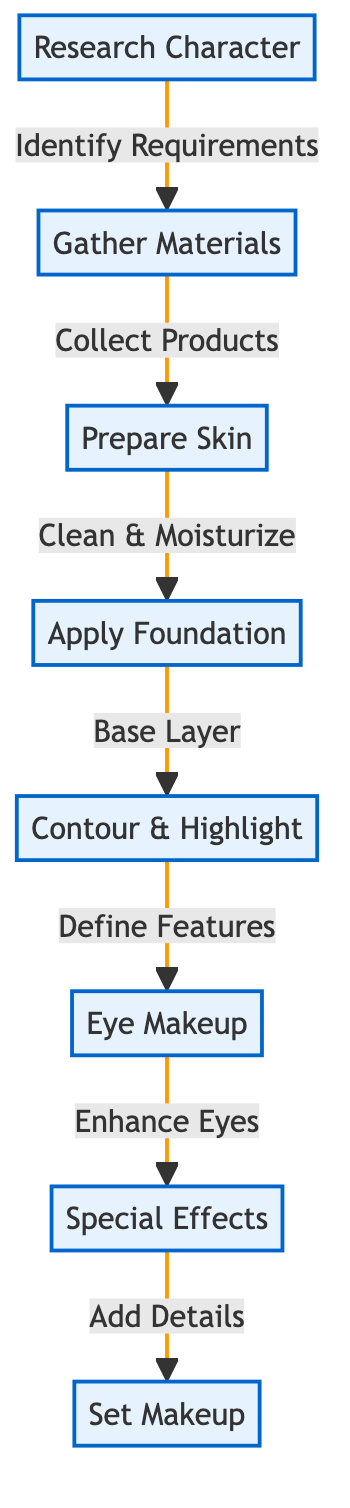What is the first step in the process of creating a movie character makeup look? The first step is represented by the node labeled "Research Character." This is the initial action identified in the diagram.
Answer: Research Character How many main steps are there in the makeup process? By counting the distinct process nodes in the diagram, we find there are eight main steps listed, from "Research Character" to "Set Makeup."
Answer: 8 What is the relationship between "Gather Materials" and "Prepare Skin"? The relationship is represented by the arrow labeled "Collect Products." This indicates that "Gather Materials" leads to the next step of "Prepare Skin."
Answer: Collect Products What is the final action in the makeup creation process? The final action is indicated by the last node in the sequence, "Set Makeup." This is the last step that follows after all other processes are completed.
Answer: Set Makeup Which step involves enhancing the eyes? The step focused on enhancing the eyes is labeled "Eye Makeup." This is the specific phase dedicated to the application of makeup for the eyes.
Answer: Eye Makeup How many transitions are there between main steps? There are seven transitions indicated by arrows connecting the various process nodes, showing the flow from one process to the next.
Answer: 7 What do you do after applying foundation? After applying foundation, the next step is "Contour & Highlight," where further makeup techniques are executed to define facial features.
Answer: Contour & Highlight What is involved in the "Prepare Skin" step? The "Prepare Skin" step includes actions summarized as "Clean & Moisturize," which prepares the skin for subsequent makeup application.
Answer: Clean & Moisturize 